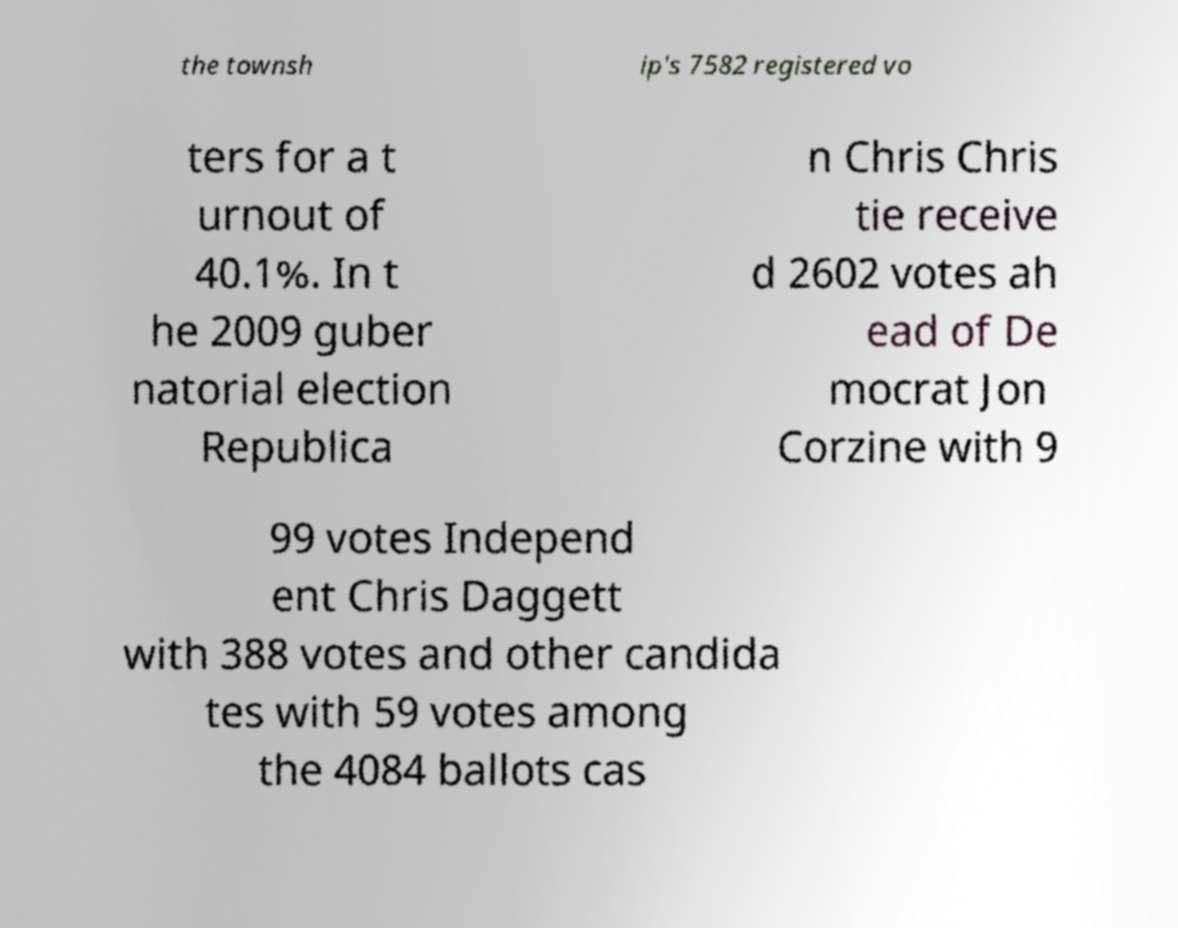Please read and relay the text visible in this image. What does it say? the townsh ip's 7582 registered vo ters for a t urnout of 40.1%. In t he 2009 guber natorial election Republica n Chris Chris tie receive d 2602 votes ah ead of De mocrat Jon Corzine with 9 99 votes Independ ent Chris Daggett with 388 votes and other candida tes with 59 votes among the 4084 ballots cas 